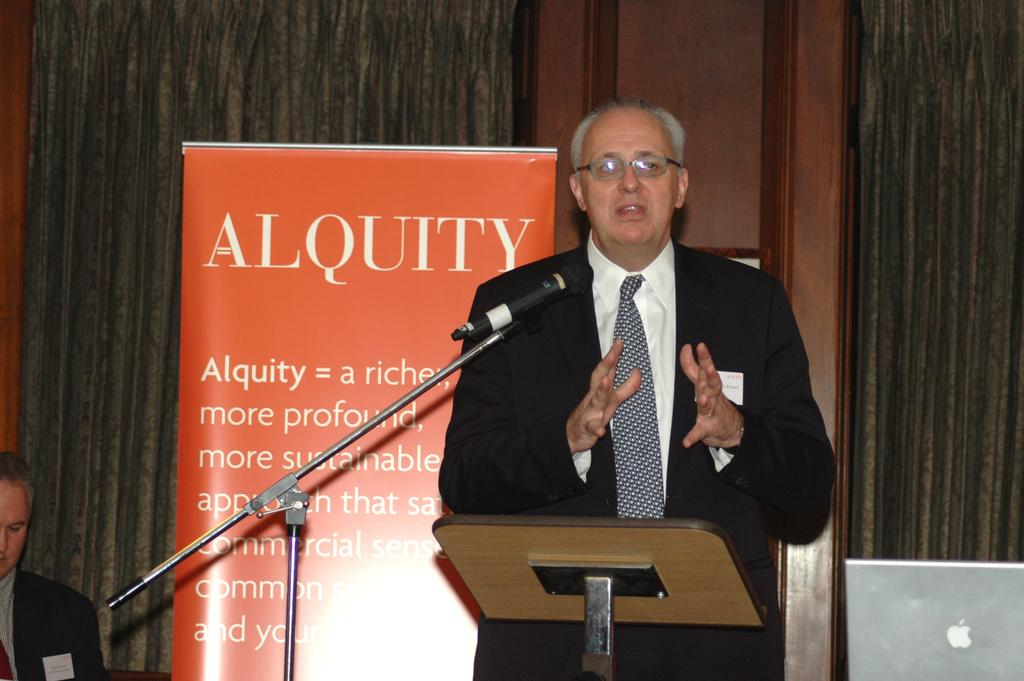What is the person near the podium doing in the image? The person is standing near a podium in the image. What is the person wearing? The person is wearing a formal suit. What can be seen hanging or displayed in the image? There is a banner visible in the image. Can you describe the seating arrangement in the image? There is a person sitting at the back in the image. How many fairies are flying around the person at the back in the image? There are no fairies present in the image. What type of rifle is the person holding while standing near the podium? There is no rifle present in the image; the person is not holding any weapon. 